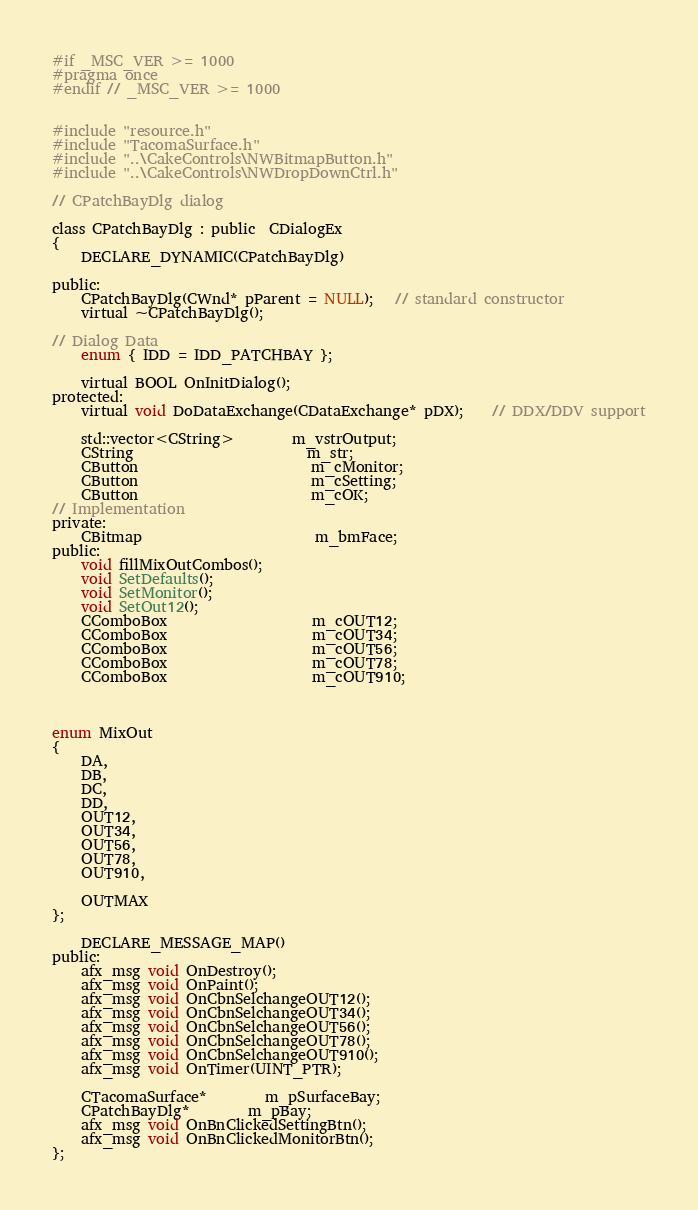<code> <loc_0><loc_0><loc_500><loc_500><_C_>#if _MSC_VER >= 1000
#pragma once
#endif // _MSC_VER >= 1000


#include "resource.h"
#include "TacomaSurface.h"
#include "..\CakeControls\NWBitmapButton.h"
#include "..\CakeControls\NWDropDownCtrl.h"

// CPatchBayDlg dialog

class CPatchBayDlg : public  CDialogEx
{
	DECLARE_DYNAMIC(CPatchBayDlg)

public:
	CPatchBayDlg(CWnd* pParent = NULL);   // standard constructor
	virtual ~CPatchBayDlg();

// Dialog Data
	enum { IDD = IDD_PATCHBAY };

	virtual BOOL OnInitDialog();
protected:
	virtual void DoDataExchange(CDataExchange* pDX);    // DDX/DDV support

	std::vector<CString>		m_vstrOutput;
	CString						m_str;
	CButton						m_cMonitor;
	CButton						m_cSetting;
	CButton						m_cOK;
// Implementation
private:
	CBitmap						m_bmFace;
public:
	void fillMixOutCombos();
	void SetDefaults();
	void SetMonitor();
	void SetOut12();
	CComboBox					m_cOUT12;
	CComboBox					m_cOUT34;
	CComboBox					m_cOUT56;
	CComboBox					m_cOUT78;
	CComboBox					m_cOUT910;



enum MixOut
{
	DA,
	DB,
	DC,
	DD,
	OUT12,
	OUT34,
	OUT56,
	OUT78,
	OUT910,

	OUTMAX
};

	DECLARE_MESSAGE_MAP()
public:
	afx_msg void OnDestroy();
	afx_msg void OnPaint();
	afx_msg void OnCbnSelchangeOUT12();
	afx_msg void OnCbnSelchangeOUT34();
	afx_msg void OnCbnSelchangeOUT56();
	afx_msg void OnCbnSelchangeOUT78();
	afx_msg void OnCbnSelchangeOUT910();
	afx_msg void OnTimer(UINT_PTR);

	CTacomaSurface*		m_pSurfaceBay;
	CPatchBayDlg*		m_pBay;
	afx_msg void OnBnClickedSettingBtn();
	afx_msg void OnBnClickedMonitorBtn();
};
</code> 